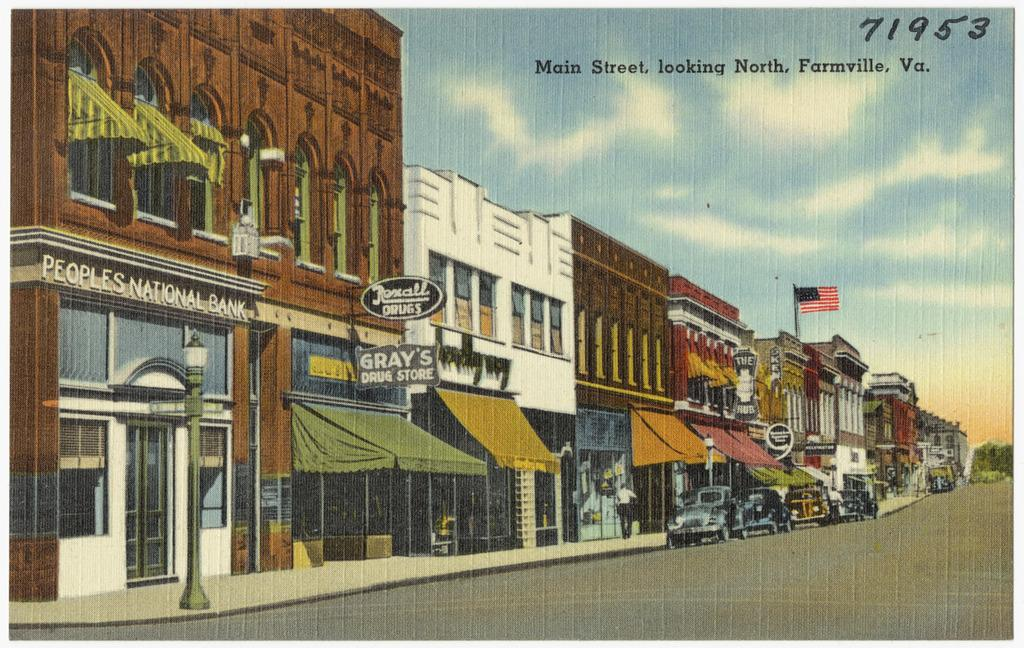What type of structures can be seen in the image? The image contains buildings. What type of vehicles are present in the image? There are cars in the image. What type of signage is visible in the image? There are boards with text in the image. What type of symbol is present in the image? There is a flag in the image. What is the weather condition in the image? The sky is cloudy in the image. What type of vegetation is visible in the image? There are trees in the image. What type of nut is being used to write on the boards in the image? There is no nut present in the image, and no writing is being done on the boards. 